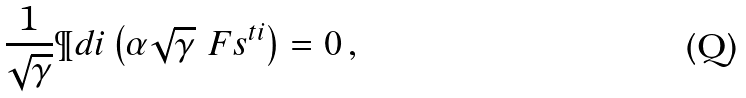<formula> <loc_0><loc_0><loc_500><loc_500>\frac { 1 } { \sqrt { \gamma } } \P d { i } \left ( \alpha \sqrt { \gamma } \ F s ^ { t i } \right ) = 0 \, ,</formula> 